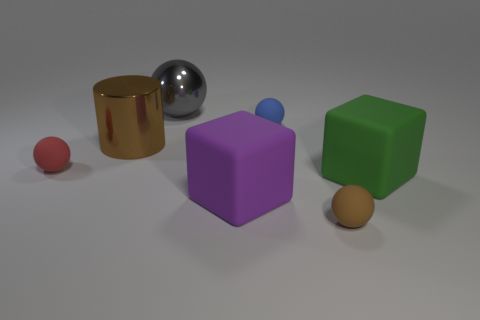Is there anything else that is the same shape as the brown metallic object?
Keep it short and to the point. No. What is the material of the object that is the same color as the metal cylinder?
Your answer should be very brief. Rubber. Are there any other things of the same shape as the small brown thing?
Provide a succinct answer. Yes. What number of red matte objects have the same shape as the gray thing?
Provide a short and direct response. 1. Are there fewer big purple blocks than cyan cylinders?
Your answer should be very brief. No. What is the brown thing behind the red rubber sphere made of?
Your response must be concise. Metal. What is the material of the red ball that is the same size as the brown matte sphere?
Your answer should be very brief. Rubber. There is a big block that is on the right side of the large thing that is in front of the big rubber thing right of the tiny brown ball; what is it made of?
Your response must be concise. Rubber. There is a brown thing right of the gray metal sphere; is it the same size as the red thing?
Keep it short and to the point. Yes. Are there more small blue rubber balls than large gray metallic blocks?
Your answer should be compact. Yes. 